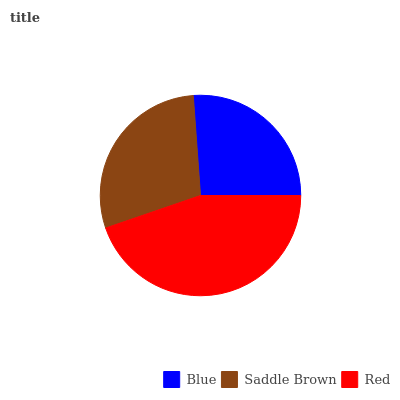Is Blue the minimum?
Answer yes or no. Yes. Is Red the maximum?
Answer yes or no. Yes. Is Saddle Brown the minimum?
Answer yes or no. No. Is Saddle Brown the maximum?
Answer yes or no. No. Is Saddle Brown greater than Blue?
Answer yes or no. Yes. Is Blue less than Saddle Brown?
Answer yes or no. Yes. Is Blue greater than Saddle Brown?
Answer yes or no. No. Is Saddle Brown less than Blue?
Answer yes or no. No. Is Saddle Brown the high median?
Answer yes or no. Yes. Is Saddle Brown the low median?
Answer yes or no. Yes. Is Red the high median?
Answer yes or no. No. Is Red the low median?
Answer yes or no. No. 